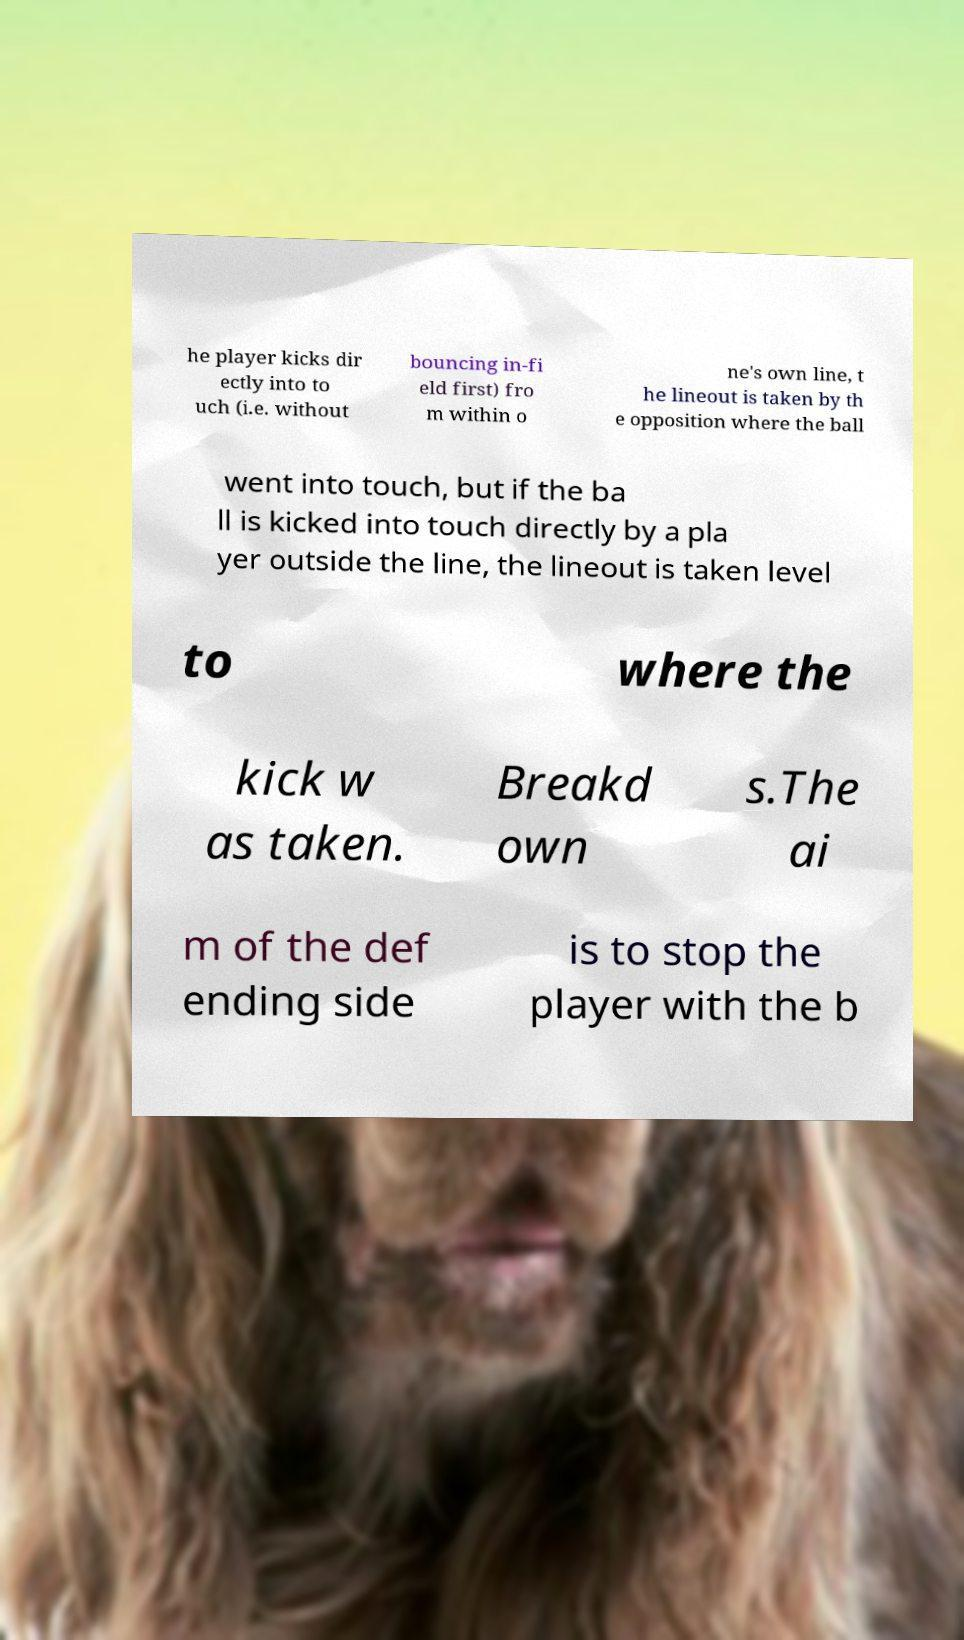Please identify and transcribe the text found in this image. he player kicks dir ectly into to uch (i.e. without bouncing in-fi eld first) fro m within o ne's own line, t he lineout is taken by th e opposition where the ball went into touch, but if the ba ll is kicked into touch directly by a pla yer outside the line, the lineout is taken level to where the kick w as taken. Breakd own s.The ai m of the def ending side is to stop the player with the b 